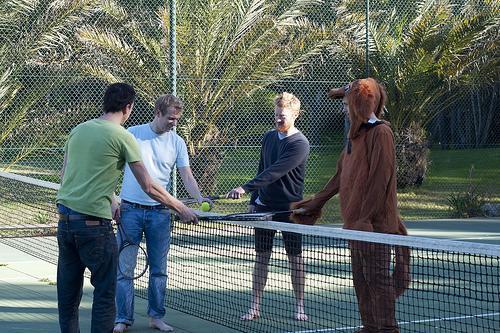How many tennis balls are there?
Give a very brief answer. 1. 